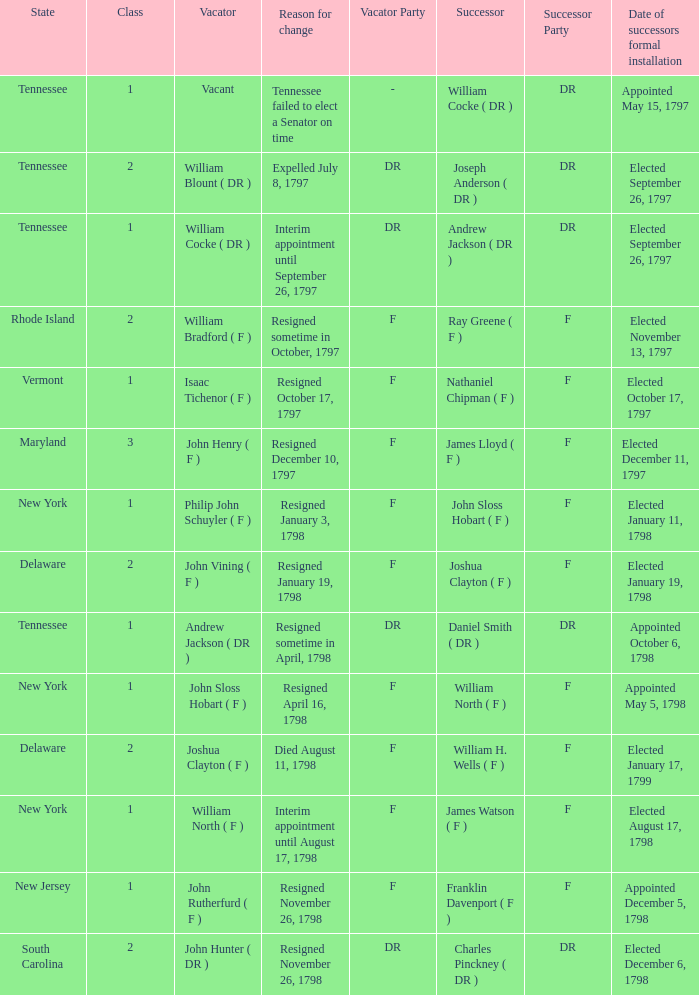What are all the states (class) when the reason for change was resigned November 26, 1798 and the vacator was John Hunter ( DR )? South Carolina (2). 